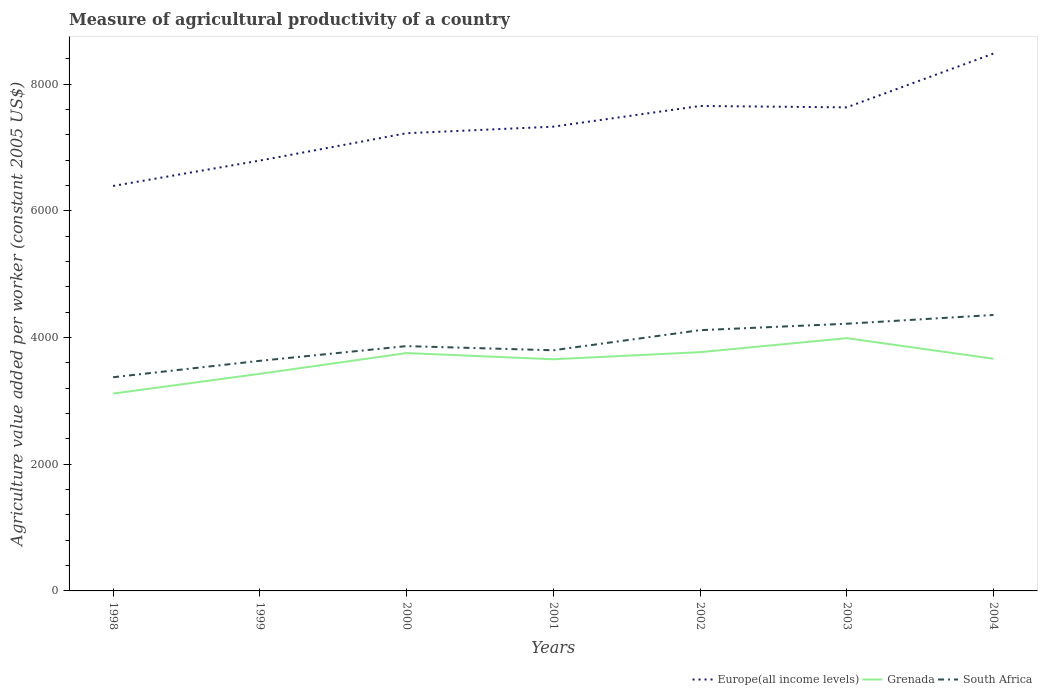How many different coloured lines are there?
Give a very brief answer. 3. Does the line corresponding to South Africa intersect with the line corresponding to Europe(all income levels)?
Your response must be concise. No. Across all years, what is the maximum measure of agricultural productivity in Grenada?
Offer a very short reply. 3116.04. In which year was the measure of agricultural productivity in South Africa maximum?
Your response must be concise. 1998. What is the total measure of agricultural productivity in South Africa in the graph?
Your answer should be very brief. -844.75. What is the difference between the highest and the second highest measure of agricultural productivity in Grenada?
Provide a succinct answer. 875.3. What is the difference between the highest and the lowest measure of agricultural productivity in Grenada?
Make the answer very short. 5. How many lines are there?
Your answer should be very brief. 3. Does the graph contain any zero values?
Ensure brevity in your answer.  No. How are the legend labels stacked?
Provide a succinct answer. Horizontal. What is the title of the graph?
Offer a terse response. Measure of agricultural productivity of a country. What is the label or title of the X-axis?
Ensure brevity in your answer.  Years. What is the label or title of the Y-axis?
Your answer should be compact. Agriculture value added per worker (constant 2005 US$). What is the Agriculture value added per worker (constant 2005 US$) in Europe(all income levels) in 1998?
Your answer should be very brief. 6394.67. What is the Agriculture value added per worker (constant 2005 US$) in Grenada in 1998?
Offer a terse response. 3116.04. What is the Agriculture value added per worker (constant 2005 US$) in South Africa in 1998?
Keep it short and to the point. 3374.27. What is the Agriculture value added per worker (constant 2005 US$) of Europe(all income levels) in 1999?
Your answer should be very brief. 6795.55. What is the Agriculture value added per worker (constant 2005 US$) of Grenada in 1999?
Provide a short and direct response. 3428.29. What is the Agriculture value added per worker (constant 2005 US$) of South Africa in 1999?
Provide a succinct answer. 3633.44. What is the Agriculture value added per worker (constant 2005 US$) of Europe(all income levels) in 2000?
Keep it short and to the point. 7227.25. What is the Agriculture value added per worker (constant 2005 US$) in Grenada in 2000?
Your answer should be very brief. 3755.84. What is the Agriculture value added per worker (constant 2005 US$) of South Africa in 2000?
Ensure brevity in your answer.  3865.82. What is the Agriculture value added per worker (constant 2005 US$) in Europe(all income levels) in 2001?
Provide a succinct answer. 7330.74. What is the Agriculture value added per worker (constant 2005 US$) in Grenada in 2001?
Make the answer very short. 3657.95. What is the Agriculture value added per worker (constant 2005 US$) in South Africa in 2001?
Ensure brevity in your answer.  3799.78. What is the Agriculture value added per worker (constant 2005 US$) in Europe(all income levels) in 2002?
Ensure brevity in your answer.  7657.57. What is the Agriculture value added per worker (constant 2005 US$) in Grenada in 2002?
Offer a very short reply. 3770.12. What is the Agriculture value added per worker (constant 2005 US$) of South Africa in 2002?
Ensure brevity in your answer.  4117.37. What is the Agriculture value added per worker (constant 2005 US$) in Europe(all income levels) in 2003?
Keep it short and to the point. 7635.81. What is the Agriculture value added per worker (constant 2005 US$) of Grenada in 2003?
Your response must be concise. 3991.34. What is the Agriculture value added per worker (constant 2005 US$) in South Africa in 2003?
Provide a short and direct response. 4219.01. What is the Agriculture value added per worker (constant 2005 US$) of Europe(all income levels) in 2004?
Your response must be concise. 8484.98. What is the Agriculture value added per worker (constant 2005 US$) of Grenada in 2004?
Your answer should be compact. 3666.22. What is the Agriculture value added per worker (constant 2005 US$) of South Africa in 2004?
Make the answer very short. 4357.4. Across all years, what is the maximum Agriculture value added per worker (constant 2005 US$) in Europe(all income levels)?
Make the answer very short. 8484.98. Across all years, what is the maximum Agriculture value added per worker (constant 2005 US$) of Grenada?
Make the answer very short. 3991.34. Across all years, what is the maximum Agriculture value added per worker (constant 2005 US$) of South Africa?
Your answer should be very brief. 4357.4. Across all years, what is the minimum Agriculture value added per worker (constant 2005 US$) in Europe(all income levels)?
Make the answer very short. 6394.67. Across all years, what is the minimum Agriculture value added per worker (constant 2005 US$) in Grenada?
Your answer should be very brief. 3116.04. Across all years, what is the minimum Agriculture value added per worker (constant 2005 US$) of South Africa?
Offer a very short reply. 3374.27. What is the total Agriculture value added per worker (constant 2005 US$) of Europe(all income levels) in the graph?
Your answer should be compact. 5.15e+04. What is the total Agriculture value added per worker (constant 2005 US$) in Grenada in the graph?
Your answer should be compact. 2.54e+04. What is the total Agriculture value added per worker (constant 2005 US$) in South Africa in the graph?
Offer a very short reply. 2.74e+04. What is the difference between the Agriculture value added per worker (constant 2005 US$) of Europe(all income levels) in 1998 and that in 1999?
Make the answer very short. -400.88. What is the difference between the Agriculture value added per worker (constant 2005 US$) of Grenada in 1998 and that in 1999?
Make the answer very short. -312.25. What is the difference between the Agriculture value added per worker (constant 2005 US$) in South Africa in 1998 and that in 1999?
Make the answer very short. -259.17. What is the difference between the Agriculture value added per worker (constant 2005 US$) of Europe(all income levels) in 1998 and that in 2000?
Give a very brief answer. -832.58. What is the difference between the Agriculture value added per worker (constant 2005 US$) of Grenada in 1998 and that in 2000?
Keep it short and to the point. -639.8. What is the difference between the Agriculture value added per worker (constant 2005 US$) of South Africa in 1998 and that in 2000?
Offer a very short reply. -491.55. What is the difference between the Agriculture value added per worker (constant 2005 US$) of Europe(all income levels) in 1998 and that in 2001?
Provide a short and direct response. -936.06. What is the difference between the Agriculture value added per worker (constant 2005 US$) of Grenada in 1998 and that in 2001?
Offer a terse response. -541.91. What is the difference between the Agriculture value added per worker (constant 2005 US$) in South Africa in 1998 and that in 2001?
Provide a succinct answer. -425.51. What is the difference between the Agriculture value added per worker (constant 2005 US$) in Europe(all income levels) in 1998 and that in 2002?
Make the answer very short. -1262.9. What is the difference between the Agriculture value added per worker (constant 2005 US$) of Grenada in 1998 and that in 2002?
Provide a succinct answer. -654.08. What is the difference between the Agriculture value added per worker (constant 2005 US$) of South Africa in 1998 and that in 2002?
Offer a terse response. -743.1. What is the difference between the Agriculture value added per worker (constant 2005 US$) of Europe(all income levels) in 1998 and that in 2003?
Give a very brief answer. -1241.14. What is the difference between the Agriculture value added per worker (constant 2005 US$) in Grenada in 1998 and that in 2003?
Keep it short and to the point. -875.3. What is the difference between the Agriculture value added per worker (constant 2005 US$) of South Africa in 1998 and that in 2003?
Offer a very short reply. -844.75. What is the difference between the Agriculture value added per worker (constant 2005 US$) of Europe(all income levels) in 1998 and that in 2004?
Ensure brevity in your answer.  -2090.31. What is the difference between the Agriculture value added per worker (constant 2005 US$) of Grenada in 1998 and that in 2004?
Offer a very short reply. -550.18. What is the difference between the Agriculture value added per worker (constant 2005 US$) in South Africa in 1998 and that in 2004?
Provide a short and direct response. -983.13. What is the difference between the Agriculture value added per worker (constant 2005 US$) in Europe(all income levels) in 1999 and that in 2000?
Your answer should be compact. -431.7. What is the difference between the Agriculture value added per worker (constant 2005 US$) in Grenada in 1999 and that in 2000?
Your answer should be compact. -327.55. What is the difference between the Agriculture value added per worker (constant 2005 US$) of South Africa in 1999 and that in 2000?
Ensure brevity in your answer.  -232.38. What is the difference between the Agriculture value added per worker (constant 2005 US$) in Europe(all income levels) in 1999 and that in 2001?
Offer a very short reply. -535.18. What is the difference between the Agriculture value added per worker (constant 2005 US$) of Grenada in 1999 and that in 2001?
Provide a short and direct response. -229.66. What is the difference between the Agriculture value added per worker (constant 2005 US$) in South Africa in 1999 and that in 2001?
Offer a terse response. -166.34. What is the difference between the Agriculture value added per worker (constant 2005 US$) in Europe(all income levels) in 1999 and that in 2002?
Provide a succinct answer. -862.02. What is the difference between the Agriculture value added per worker (constant 2005 US$) in Grenada in 1999 and that in 2002?
Offer a terse response. -341.83. What is the difference between the Agriculture value added per worker (constant 2005 US$) of South Africa in 1999 and that in 2002?
Your answer should be very brief. -483.93. What is the difference between the Agriculture value added per worker (constant 2005 US$) of Europe(all income levels) in 1999 and that in 2003?
Give a very brief answer. -840.26. What is the difference between the Agriculture value added per worker (constant 2005 US$) of Grenada in 1999 and that in 2003?
Keep it short and to the point. -563.05. What is the difference between the Agriculture value added per worker (constant 2005 US$) of South Africa in 1999 and that in 2003?
Make the answer very short. -585.57. What is the difference between the Agriculture value added per worker (constant 2005 US$) in Europe(all income levels) in 1999 and that in 2004?
Make the answer very short. -1689.43. What is the difference between the Agriculture value added per worker (constant 2005 US$) in Grenada in 1999 and that in 2004?
Offer a terse response. -237.93. What is the difference between the Agriculture value added per worker (constant 2005 US$) of South Africa in 1999 and that in 2004?
Your answer should be very brief. -723.96. What is the difference between the Agriculture value added per worker (constant 2005 US$) in Europe(all income levels) in 2000 and that in 2001?
Provide a short and direct response. -103.48. What is the difference between the Agriculture value added per worker (constant 2005 US$) in Grenada in 2000 and that in 2001?
Give a very brief answer. 97.89. What is the difference between the Agriculture value added per worker (constant 2005 US$) of South Africa in 2000 and that in 2001?
Your response must be concise. 66.04. What is the difference between the Agriculture value added per worker (constant 2005 US$) in Europe(all income levels) in 2000 and that in 2002?
Your answer should be compact. -430.32. What is the difference between the Agriculture value added per worker (constant 2005 US$) of Grenada in 2000 and that in 2002?
Offer a very short reply. -14.28. What is the difference between the Agriculture value added per worker (constant 2005 US$) in South Africa in 2000 and that in 2002?
Offer a very short reply. -251.55. What is the difference between the Agriculture value added per worker (constant 2005 US$) of Europe(all income levels) in 2000 and that in 2003?
Offer a terse response. -408.56. What is the difference between the Agriculture value added per worker (constant 2005 US$) of Grenada in 2000 and that in 2003?
Offer a very short reply. -235.5. What is the difference between the Agriculture value added per worker (constant 2005 US$) of South Africa in 2000 and that in 2003?
Provide a short and direct response. -353.19. What is the difference between the Agriculture value added per worker (constant 2005 US$) of Europe(all income levels) in 2000 and that in 2004?
Provide a succinct answer. -1257.73. What is the difference between the Agriculture value added per worker (constant 2005 US$) of Grenada in 2000 and that in 2004?
Make the answer very short. 89.62. What is the difference between the Agriculture value added per worker (constant 2005 US$) in South Africa in 2000 and that in 2004?
Your response must be concise. -491.58. What is the difference between the Agriculture value added per worker (constant 2005 US$) of Europe(all income levels) in 2001 and that in 2002?
Your answer should be very brief. -326.84. What is the difference between the Agriculture value added per worker (constant 2005 US$) of Grenada in 2001 and that in 2002?
Offer a very short reply. -112.17. What is the difference between the Agriculture value added per worker (constant 2005 US$) of South Africa in 2001 and that in 2002?
Keep it short and to the point. -317.59. What is the difference between the Agriculture value added per worker (constant 2005 US$) in Europe(all income levels) in 2001 and that in 2003?
Offer a very short reply. -305.08. What is the difference between the Agriculture value added per worker (constant 2005 US$) in Grenada in 2001 and that in 2003?
Offer a very short reply. -333.39. What is the difference between the Agriculture value added per worker (constant 2005 US$) in South Africa in 2001 and that in 2003?
Provide a succinct answer. -419.23. What is the difference between the Agriculture value added per worker (constant 2005 US$) in Europe(all income levels) in 2001 and that in 2004?
Give a very brief answer. -1154.24. What is the difference between the Agriculture value added per worker (constant 2005 US$) of Grenada in 2001 and that in 2004?
Your answer should be very brief. -8.27. What is the difference between the Agriculture value added per worker (constant 2005 US$) in South Africa in 2001 and that in 2004?
Provide a short and direct response. -557.62. What is the difference between the Agriculture value added per worker (constant 2005 US$) in Europe(all income levels) in 2002 and that in 2003?
Your response must be concise. 21.76. What is the difference between the Agriculture value added per worker (constant 2005 US$) of Grenada in 2002 and that in 2003?
Keep it short and to the point. -221.22. What is the difference between the Agriculture value added per worker (constant 2005 US$) in South Africa in 2002 and that in 2003?
Ensure brevity in your answer.  -101.65. What is the difference between the Agriculture value added per worker (constant 2005 US$) in Europe(all income levels) in 2002 and that in 2004?
Your response must be concise. -827.41. What is the difference between the Agriculture value added per worker (constant 2005 US$) in Grenada in 2002 and that in 2004?
Provide a succinct answer. 103.9. What is the difference between the Agriculture value added per worker (constant 2005 US$) in South Africa in 2002 and that in 2004?
Ensure brevity in your answer.  -240.03. What is the difference between the Agriculture value added per worker (constant 2005 US$) in Europe(all income levels) in 2003 and that in 2004?
Provide a succinct answer. -849.17. What is the difference between the Agriculture value added per worker (constant 2005 US$) of Grenada in 2003 and that in 2004?
Provide a succinct answer. 325.12. What is the difference between the Agriculture value added per worker (constant 2005 US$) in South Africa in 2003 and that in 2004?
Offer a very short reply. -138.39. What is the difference between the Agriculture value added per worker (constant 2005 US$) of Europe(all income levels) in 1998 and the Agriculture value added per worker (constant 2005 US$) of Grenada in 1999?
Your response must be concise. 2966.38. What is the difference between the Agriculture value added per worker (constant 2005 US$) in Europe(all income levels) in 1998 and the Agriculture value added per worker (constant 2005 US$) in South Africa in 1999?
Provide a succinct answer. 2761.24. What is the difference between the Agriculture value added per worker (constant 2005 US$) of Grenada in 1998 and the Agriculture value added per worker (constant 2005 US$) of South Africa in 1999?
Offer a very short reply. -517.4. What is the difference between the Agriculture value added per worker (constant 2005 US$) of Europe(all income levels) in 1998 and the Agriculture value added per worker (constant 2005 US$) of Grenada in 2000?
Offer a very short reply. 2638.83. What is the difference between the Agriculture value added per worker (constant 2005 US$) of Europe(all income levels) in 1998 and the Agriculture value added per worker (constant 2005 US$) of South Africa in 2000?
Offer a very short reply. 2528.86. What is the difference between the Agriculture value added per worker (constant 2005 US$) in Grenada in 1998 and the Agriculture value added per worker (constant 2005 US$) in South Africa in 2000?
Ensure brevity in your answer.  -749.78. What is the difference between the Agriculture value added per worker (constant 2005 US$) in Europe(all income levels) in 1998 and the Agriculture value added per worker (constant 2005 US$) in Grenada in 2001?
Give a very brief answer. 2736.72. What is the difference between the Agriculture value added per worker (constant 2005 US$) of Europe(all income levels) in 1998 and the Agriculture value added per worker (constant 2005 US$) of South Africa in 2001?
Your answer should be compact. 2594.89. What is the difference between the Agriculture value added per worker (constant 2005 US$) in Grenada in 1998 and the Agriculture value added per worker (constant 2005 US$) in South Africa in 2001?
Your answer should be very brief. -683.74. What is the difference between the Agriculture value added per worker (constant 2005 US$) in Europe(all income levels) in 1998 and the Agriculture value added per worker (constant 2005 US$) in Grenada in 2002?
Offer a terse response. 2624.55. What is the difference between the Agriculture value added per worker (constant 2005 US$) in Europe(all income levels) in 1998 and the Agriculture value added per worker (constant 2005 US$) in South Africa in 2002?
Offer a terse response. 2277.31. What is the difference between the Agriculture value added per worker (constant 2005 US$) of Grenada in 1998 and the Agriculture value added per worker (constant 2005 US$) of South Africa in 2002?
Your answer should be compact. -1001.32. What is the difference between the Agriculture value added per worker (constant 2005 US$) in Europe(all income levels) in 1998 and the Agriculture value added per worker (constant 2005 US$) in Grenada in 2003?
Offer a very short reply. 2403.33. What is the difference between the Agriculture value added per worker (constant 2005 US$) in Europe(all income levels) in 1998 and the Agriculture value added per worker (constant 2005 US$) in South Africa in 2003?
Provide a succinct answer. 2175.66. What is the difference between the Agriculture value added per worker (constant 2005 US$) of Grenada in 1998 and the Agriculture value added per worker (constant 2005 US$) of South Africa in 2003?
Provide a succinct answer. -1102.97. What is the difference between the Agriculture value added per worker (constant 2005 US$) in Europe(all income levels) in 1998 and the Agriculture value added per worker (constant 2005 US$) in Grenada in 2004?
Your answer should be compact. 2728.45. What is the difference between the Agriculture value added per worker (constant 2005 US$) of Europe(all income levels) in 1998 and the Agriculture value added per worker (constant 2005 US$) of South Africa in 2004?
Make the answer very short. 2037.28. What is the difference between the Agriculture value added per worker (constant 2005 US$) of Grenada in 1998 and the Agriculture value added per worker (constant 2005 US$) of South Africa in 2004?
Your answer should be very brief. -1241.36. What is the difference between the Agriculture value added per worker (constant 2005 US$) of Europe(all income levels) in 1999 and the Agriculture value added per worker (constant 2005 US$) of Grenada in 2000?
Offer a very short reply. 3039.71. What is the difference between the Agriculture value added per worker (constant 2005 US$) of Europe(all income levels) in 1999 and the Agriculture value added per worker (constant 2005 US$) of South Africa in 2000?
Provide a succinct answer. 2929.74. What is the difference between the Agriculture value added per worker (constant 2005 US$) in Grenada in 1999 and the Agriculture value added per worker (constant 2005 US$) in South Africa in 2000?
Make the answer very short. -437.52. What is the difference between the Agriculture value added per worker (constant 2005 US$) in Europe(all income levels) in 1999 and the Agriculture value added per worker (constant 2005 US$) in Grenada in 2001?
Your response must be concise. 3137.6. What is the difference between the Agriculture value added per worker (constant 2005 US$) in Europe(all income levels) in 1999 and the Agriculture value added per worker (constant 2005 US$) in South Africa in 2001?
Make the answer very short. 2995.77. What is the difference between the Agriculture value added per worker (constant 2005 US$) of Grenada in 1999 and the Agriculture value added per worker (constant 2005 US$) of South Africa in 2001?
Ensure brevity in your answer.  -371.49. What is the difference between the Agriculture value added per worker (constant 2005 US$) of Europe(all income levels) in 1999 and the Agriculture value added per worker (constant 2005 US$) of Grenada in 2002?
Your response must be concise. 3025.43. What is the difference between the Agriculture value added per worker (constant 2005 US$) in Europe(all income levels) in 1999 and the Agriculture value added per worker (constant 2005 US$) in South Africa in 2002?
Your answer should be very brief. 2678.19. What is the difference between the Agriculture value added per worker (constant 2005 US$) of Grenada in 1999 and the Agriculture value added per worker (constant 2005 US$) of South Africa in 2002?
Provide a short and direct response. -689.07. What is the difference between the Agriculture value added per worker (constant 2005 US$) in Europe(all income levels) in 1999 and the Agriculture value added per worker (constant 2005 US$) in Grenada in 2003?
Your answer should be very brief. 2804.21. What is the difference between the Agriculture value added per worker (constant 2005 US$) in Europe(all income levels) in 1999 and the Agriculture value added per worker (constant 2005 US$) in South Africa in 2003?
Your answer should be compact. 2576.54. What is the difference between the Agriculture value added per worker (constant 2005 US$) of Grenada in 1999 and the Agriculture value added per worker (constant 2005 US$) of South Africa in 2003?
Make the answer very short. -790.72. What is the difference between the Agriculture value added per worker (constant 2005 US$) of Europe(all income levels) in 1999 and the Agriculture value added per worker (constant 2005 US$) of Grenada in 2004?
Give a very brief answer. 3129.33. What is the difference between the Agriculture value added per worker (constant 2005 US$) in Europe(all income levels) in 1999 and the Agriculture value added per worker (constant 2005 US$) in South Africa in 2004?
Offer a very short reply. 2438.15. What is the difference between the Agriculture value added per worker (constant 2005 US$) of Grenada in 1999 and the Agriculture value added per worker (constant 2005 US$) of South Africa in 2004?
Provide a short and direct response. -929.11. What is the difference between the Agriculture value added per worker (constant 2005 US$) in Europe(all income levels) in 2000 and the Agriculture value added per worker (constant 2005 US$) in Grenada in 2001?
Provide a short and direct response. 3569.3. What is the difference between the Agriculture value added per worker (constant 2005 US$) of Europe(all income levels) in 2000 and the Agriculture value added per worker (constant 2005 US$) of South Africa in 2001?
Ensure brevity in your answer.  3427.47. What is the difference between the Agriculture value added per worker (constant 2005 US$) in Grenada in 2000 and the Agriculture value added per worker (constant 2005 US$) in South Africa in 2001?
Ensure brevity in your answer.  -43.94. What is the difference between the Agriculture value added per worker (constant 2005 US$) in Europe(all income levels) in 2000 and the Agriculture value added per worker (constant 2005 US$) in Grenada in 2002?
Make the answer very short. 3457.13. What is the difference between the Agriculture value added per worker (constant 2005 US$) of Europe(all income levels) in 2000 and the Agriculture value added per worker (constant 2005 US$) of South Africa in 2002?
Your answer should be compact. 3109.89. What is the difference between the Agriculture value added per worker (constant 2005 US$) of Grenada in 2000 and the Agriculture value added per worker (constant 2005 US$) of South Africa in 2002?
Give a very brief answer. -361.52. What is the difference between the Agriculture value added per worker (constant 2005 US$) in Europe(all income levels) in 2000 and the Agriculture value added per worker (constant 2005 US$) in Grenada in 2003?
Your answer should be very brief. 3235.91. What is the difference between the Agriculture value added per worker (constant 2005 US$) in Europe(all income levels) in 2000 and the Agriculture value added per worker (constant 2005 US$) in South Africa in 2003?
Keep it short and to the point. 3008.24. What is the difference between the Agriculture value added per worker (constant 2005 US$) of Grenada in 2000 and the Agriculture value added per worker (constant 2005 US$) of South Africa in 2003?
Offer a terse response. -463.17. What is the difference between the Agriculture value added per worker (constant 2005 US$) of Europe(all income levels) in 2000 and the Agriculture value added per worker (constant 2005 US$) of Grenada in 2004?
Your answer should be very brief. 3561.03. What is the difference between the Agriculture value added per worker (constant 2005 US$) of Europe(all income levels) in 2000 and the Agriculture value added per worker (constant 2005 US$) of South Africa in 2004?
Provide a short and direct response. 2869.85. What is the difference between the Agriculture value added per worker (constant 2005 US$) in Grenada in 2000 and the Agriculture value added per worker (constant 2005 US$) in South Africa in 2004?
Your response must be concise. -601.55. What is the difference between the Agriculture value added per worker (constant 2005 US$) in Europe(all income levels) in 2001 and the Agriculture value added per worker (constant 2005 US$) in Grenada in 2002?
Offer a terse response. 3560.61. What is the difference between the Agriculture value added per worker (constant 2005 US$) in Europe(all income levels) in 2001 and the Agriculture value added per worker (constant 2005 US$) in South Africa in 2002?
Your answer should be compact. 3213.37. What is the difference between the Agriculture value added per worker (constant 2005 US$) of Grenada in 2001 and the Agriculture value added per worker (constant 2005 US$) of South Africa in 2002?
Ensure brevity in your answer.  -459.41. What is the difference between the Agriculture value added per worker (constant 2005 US$) in Europe(all income levels) in 2001 and the Agriculture value added per worker (constant 2005 US$) in Grenada in 2003?
Offer a very short reply. 3339.39. What is the difference between the Agriculture value added per worker (constant 2005 US$) of Europe(all income levels) in 2001 and the Agriculture value added per worker (constant 2005 US$) of South Africa in 2003?
Keep it short and to the point. 3111.72. What is the difference between the Agriculture value added per worker (constant 2005 US$) in Grenada in 2001 and the Agriculture value added per worker (constant 2005 US$) in South Africa in 2003?
Offer a terse response. -561.06. What is the difference between the Agriculture value added per worker (constant 2005 US$) in Europe(all income levels) in 2001 and the Agriculture value added per worker (constant 2005 US$) in Grenada in 2004?
Offer a very short reply. 3664.52. What is the difference between the Agriculture value added per worker (constant 2005 US$) of Europe(all income levels) in 2001 and the Agriculture value added per worker (constant 2005 US$) of South Africa in 2004?
Give a very brief answer. 2973.34. What is the difference between the Agriculture value added per worker (constant 2005 US$) in Grenada in 2001 and the Agriculture value added per worker (constant 2005 US$) in South Africa in 2004?
Offer a very short reply. -699.45. What is the difference between the Agriculture value added per worker (constant 2005 US$) in Europe(all income levels) in 2002 and the Agriculture value added per worker (constant 2005 US$) in Grenada in 2003?
Offer a very short reply. 3666.23. What is the difference between the Agriculture value added per worker (constant 2005 US$) of Europe(all income levels) in 2002 and the Agriculture value added per worker (constant 2005 US$) of South Africa in 2003?
Your answer should be compact. 3438.56. What is the difference between the Agriculture value added per worker (constant 2005 US$) in Grenada in 2002 and the Agriculture value added per worker (constant 2005 US$) in South Africa in 2003?
Give a very brief answer. -448.89. What is the difference between the Agriculture value added per worker (constant 2005 US$) in Europe(all income levels) in 2002 and the Agriculture value added per worker (constant 2005 US$) in Grenada in 2004?
Provide a short and direct response. 3991.35. What is the difference between the Agriculture value added per worker (constant 2005 US$) of Europe(all income levels) in 2002 and the Agriculture value added per worker (constant 2005 US$) of South Africa in 2004?
Your answer should be very brief. 3300.17. What is the difference between the Agriculture value added per worker (constant 2005 US$) of Grenada in 2002 and the Agriculture value added per worker (constant 2005 US$) of South Africa in 2004?
Your answer should be compact. -587.28. What is the difference between the Agriculture value added per worker (constant 2005 US$) in Europe(all income levels) in 2003 and the Agriculture value added per worker (constant 2005 US$) in Grenada in 2004?
Provide a succinct answer. 3969.59. What is the difference between the Agriculture value added per worker (constant 2005 US$) of Europe(all income levels) in 2003 and the Agriculture value added per worker (constant 2005 US$) of South Africa in 2004?
Provide a succinct answer. 3278.41. What is the difference between the Agriculture value added per worker (constant 2005 US$) in Grenada in 2003 and the Agriculture value added per worker (constant 2005 US$) in South Africa in 2004?
Offer a very short reply. -366.06. What is the average Agriculture value added per worker (constant 2005 US$) in Europe(all income levels) per year?
Your answer should be compact. 7360.94. What is the average Agriculture value added per worker (constant 2005 US$) of Grenada per year?
Provide a succinct answer. 3626.55. What is the average Agriculture value added per worker (constant 2005 US$) of South Africa per year?
Your response must be concise. 3909.58. In the year 1998, what is the difference between the Agriculture value added per worker (constant 2005 US$) of Europe(all income levels) and Agriculture value added per worker (constant 2005 US$) of Grenada?
Your answer should be compact. 3278.63. In the year 1998, what is the difference between the Agriculture value added per worker (constant 2005 US$) of Europe(all income levels) and Agriculture value added per worker (constant 2005 US$) of South Africa?
Offer a terse response. 3020.41. In the year 1998, what is the difference between the Agriculture value added per worker (constant 2005 US$) of Grenada and Agriculture value added per worker (constant 2005 US$) of South Africa?
Your response must be concise. -258.22. In the year 1999, what is the difference between the Agriculture value added per worker (constant 2005 US$) of Europe(all income levels) and Agriculture value added per worker (constant 2005 US$) of Grenada?
Offer a very short reply. 3367.26. In the year 1999, what is the difference between the Agriculture value added per worker (constant 2005 US$) of Europe(all income levels) and Agriculture value added per worker (constant 2005 US$) of South Africa?
Make the answer very short. 3162.11. In the year 1999, what is the difference between the Agriculture value added per worker (constant 2005 US$) of Grenada and Agriculture value added per worker (constant 2005 US$) of South Africa?
Ensure brevity in your answer.  -205.15. In the year 2000, what is the difference between the Agriculture value added per worker (constant 2005 US$) of Europe(all income levels) and Agriculture value added per worker (constant 2005 US$) of Grenada?
Provide a succinct answer. 3471.41. In the year 2000, what is the difference between the Agriculture value added per worker (constant 2005 US$) of Europe(all income levels) and Agriculture value added per worker (constant 2005 US$) of South Africa?
Offer a very short reply. 3361.44. In the year 2000, what is the difference between the Agriculture value added per worker (constant 2005 US$) of Grenada and Agriculture value added per worker (constant 2005 US$) of South Africa?
Provide a short and direct response. -109.97. In the year 2001, what is the difference between the Agriculture value added per worker (constant 2005 US$) in Europe(all income levels) and Agriculture value added per worker (constant 2005 US$) in Grenada?
Offer a terse response. 3672.78. In the year 2001, what is the difference between the Agriculture value added per worker (constant 2005 US$) in Europe(all income levels) and Agriculture value added per worker (constant 2005 US$) in South Africa?
Your answer should be very brief. 3530.96. In the year 2001, what is the difference between the Agriculture value added per worker (constant 2005 US$) of Grenada and Agriculture value added per worker (constant 2005 US$) of South Africa?
Your answer should be compact. -141.83. In the year 2002, what is the difference between the Agriculture value added per worker (constant 2005 US$) in Europe(all income levels) and Agriculture value added per worker (constant 2005 US$) in Grenada?
Ensure brevity in your answer.  3887.45. In the year 2002, what is the difference between the Agriculture value added per worker (constant 2005 US$) of Europe(all income levels) and Agriculture value added per worker (constant 2005 US$) of South Africa?
Your answer should be very brief. 3540.21. In the year 2002, what is the difference between the Agriculture value added per worker (constant 2005 US$) of Grenada and Agriculture value added per worker (constant 2005 US$) of South Africa?
Ensure brevity in your answer.  -347.24. In the year 2003, what is the difference between the Agriculture value added per worker (constant 2005 US$) in Europe(all income levels) and Agriculture value added per worker (constant 2005 US$) in Grenada?
Keep it short and to the point. 3644.47. In the year 2003, what is the difference between the Agriculture value added per worker (constant 2005 US$) in Europe(all income levels) and Agriculture value added per worker (constant 2005 US$) in South Africa?
Make the answer very short. 3416.8. In the year 2003, what is the difference between the Agriculture value added per worker (constant 2005 US$) of Grenada and Agriculture value added per worker (constant 2005 US$) of South Africa?
Keep it short and to the point. -227.67. In the year 2004, what is the difference between the Agriculture value added per worker (constant 2005 US$) in Europe(all income levels) and Agriculture value added per worker (constant 2005 US$) in Grenada?
Give a very brief answer. 4818.76. In the year 2004, what is the difference between the Agriculture value added per worker (constant 2005 US$) in Europe(all income levels) and Agriculture value added per worker (constant 2005 US$) in South Africa?
Offer a very short reply. 4127.58. In the year 2004, what is the difference between the Agriculture value added per worker (constant 2005 US$) in Grenada and Agriculture value added per worker (constant 2005 US$) in South Africa?
Keep it short and to the point. -691.18. What is the ratio of the Agriculture value added per worker (constant 2005 US$) of Europe(all income levels) in 1998 to that in 1999?
Provide a short and direct response. 0.94. What is the ratio of the Agriculture value added per worker (constant 2005 US$) of Grenada in 1998 to that in 1999?
Your response must be concise. 0.91. What is the ratio of the Agriculture value added per worker (constant 2005 US$) of South Africa in 1998 to that in 1999?
Your response must be concise. 0.93. What is the ratio of the Agriculture value added per worker (constant 2005 US$) of Europe(all income levels) in 1998 to that in 2000?
Make the answer very short. 0.88. What is the ratio of the Agriculture value added per worker (constant 2005 US$) of Grenada in 1998 to that in 2000?
Your answer should be compact. 0.83. What is the ratio of the Agriculture value added per worker (constant 2005 US$) in South Africa in 1998 to that in 2000?
Provide a succinct answer. 0.87. What is the ratio of the Agriculture value added per worker (constant 2005 US$) of Europe(all income levels) in 1998 to that in 2001?
Offer a very short reply. 0.87. What is the ratio of the Agriculture value added per worker (constant 2005 US$) of Grenada in 1998 to that in 2001?
Provide a succinct answer. 0.85. What is the ratio of the Agriculture value added per worker (constant 2005 US$) of South Africa in 1998 to that in 2001?
Provide a short and direct response. 0.89. What is the ratio of the Agriculture value added per worker (constant 2005 US$) of Europe(all income levels) in 1998 to that in 2002?
Offer a very short reply. 0.84. What is the ratio of the Agriculture value added per worker (constant 2005 US$) in Grenada in 1998 to that in 2002?
Your answer should be compact. 0.83. What is the ratio of the Agriculture value added per worker (constant 2005 US$) of South Africa in 1998 to that in 2002?
Your answer should be very brief. 0.82. What is the ratio of the Agriculture value added per worker (constant 2005 US$) in Europe(all income levels) in 1998 to that in 2003?
Your response must be concise. 0.84. What is the ratio of the Agriculture value added per worker (constant 2005 US$) in Grenada in 1998 to that in 2003?
Your answer should be very brief. 0.78. What is the ratio of the Agriculture value added per worker (constant 2005 US$) in South Africa in 1998 to that in 2003?
Provide a succinct answer. 0.8. What is the ratio of the Agriculture value added per worker (constant 2005 US$) of Europe(all income levels) in 1998 to that in 2004?
Keep it short and to the point. 0.75. What is the ratio of the Agriculture value added per worker (constant 2005 US$) of Grenada in 1998 to that in 2004?
Ensure brevity in your answer.  0.85. What is the ratio of the Agriculture value added per worker (constant 2005 US$) of South Africa in 1998 to that in 2004?
Offer a very short reply. 0.77. What is the ratio of the Agriculture value added per worker (constant 2005 US$) of Europe(all income levels) in 1999 to that in 2000?
Your answer should be compact. 0.94. What is the ratio of the Agriculture value added per worker (constant 2005 US$) in Grenada in 1999 to that in 2000?
Your response must be concise. 0.91. What is the ratio of the Agriculture value added per worker (constant 2005 US$) of South Africa in 1999 to that in 2000?
Provide a succinct answer. 0.94. What is the ratio of the Agriculture value added per worker (constant 2005 US$) of Europe(all income levels) in 1999 to that in 2001?
Your response must be concise. 0.93. What is the ratio of the Agriculture value added per worker (constant 2005 US$) in Grenada in 1999 to that in 2001?
Offer a very short reply. 0.94. What is the ratio of the Agriculture value added per worker (constant 2005 US$) of South Africa in 1999 to that in 2001?
Your answer should be compact. 0.96. What is the ratio of the Agriculture value added per worker (constant 2005 US$) of Europe(all income levels) in 1999 to that in 2002?
Your response must be concise. 0.89. What is the ratio of the Agriculture value added per worker (constant 2005 US$) in Grenada in 1999 to that in 2002?
Your answer should be very brief. 0.91. What is the ratio of the Agriculture value added per worker (constant 2005 US$) of South Africa in 1999 to that in 2002?
Your response must be concise. 0.88. What is the ratio of the Agriculture value added per worker (constant 2005 US$) in Europe(all income levels) in 1999 to that in 2003?
Provide a succinct answer. 0.89. What is the ratio of the Agriculture value added per worker (constant 2005 US$) of Grenada in 1999 to that in 2003?
Your answer should be very brief. 0.86. What is the ratio of the Agriculture value added per worker (constant 2005 US$) in South Africa in 1999 to that in 2003?
Provide a succinct answer. 0.86. What is the ratio of the Agriculture value added per worker (constant 2005 US$) in Europe(all income levels) in 1999 to that in 2004?
Keep it short and to the point. 0.8. What is the ratio of the Agriculture value added per worker (constant 2005 US$) of Grenada in 1999 to that in 2004?
Keep it short and to the point. 0.94. What is the ratio of the Agriculture value added per worker (constant 2005 US$) of South Africa in 1999 to that in 2004?
Offer a terse response. 0.83. What is the ratio of the Agriculture value added per worker (constant 2005 US$) in Europe(all income levels) in 2000 to that in 2001?
Provide a succinct answer. 0.99. What is the ratio of the Agriculture value added per worker (constant 2005 US$) in Grenada in 2000 to that in 2001?
Provide a short and direct response. 1.03. What is the ratio of the Agriculture value added per worker (constant 2005 US$) of South Africa in 2000 to that in 2001?
Provide a succinct answer. 1.02. What is the ratio of the Agriculture value added per worker (constant 2005 US$) of Europe(all income levels) in 2000 to that in 2002?
Offer a terse response. 0.94. What is the ratio of the Agriculture value added per worker (constant 2005 US$) in Grenada in 2000 to that in 2002?
Provide a short and direct response. 1. What is the ratio of the Agriculture value added per worker (constant 2005 US$) of South Africa in 2000 to that in 2002?
Make the answer very short. 0.94. What is the ratio of the Agriculture value added per worker (constant 2005 US$) of Europe(all income levels) in 2000 to that in 2003?
Ensure brevity in your answer.  0.95. What is the ratio of the Agriculture value added per worker (constant 2005 US$) of Grenada in 2000 to that in 2003?
Your answer should be compact. 0.94. What is the ratio of the Agriculture value added per worker (constant 2005 US$) of South Africa in 2000 to that in 2003?
Your response must be concise. 0.92. What is the ratio of the Agriculture value added per worker (constant 2005 US$) of Europe(all income levels) in 2000 to that in 2004?
Provide a succinct answer. 0.85. What is the ratio of the Agriculture value added per worker (constant 2005 US$) of Grenada in 2000 to that in 2004?
Offer a very short reply. 1.02. What is the ratio of the Agriculture value added per worker (constant 2005 US$) of South Africa in 2000 to that in 2004?
Offer a terse response. 0.89. What is the ratio of the Agriculture value added per worker (constant 2005 US$) of Europe(all income levels) in 2001 to that in 2002?
Offer a terse response. 0.96. What is the ratio of the Agriculture value added per worker (constant 2005 US$) in Grenada in 2001 to that in 2002?
Offer a terse response. 0.97. What is the ratio of the Agriculture value added per worker (constant 2005 US$) of South Africa in 2001 to that in 2002?
Your response must be concise. 0.92. What is the ratio of the Agriculture value added per worker (constant 2005 US$) of Europe(all income levels) in 2001 to that in 2003?
Offer a terse response. 0.96. What is the ratio of the Agriculture value added per worker (constant 2005 US$) in Grenada in 2001 to that in 2003?
Ensure brevity in your answer.  0.92. What is the ratio of the Agriculture value added per worker (constant 2005 US$) in South Africa in 2001 to that in 2003?
Your answer should be compact. 0.9. What is the ratio of the Agriculture value added per worker (constant 2005 US$) in Europe(all income levels) in 2001 to that in 2004?
Offer a terse response. 0.86. What is the ratio of the Agriculture value added per worker (constant 2005 US$) of South Africa in 2001 to that in 2004?
Ensure brevity in your answer.  0.87. What is the ratio of the Agriculture value added per worker (constant 2005 US$) in Grenada in 2002 to that in 2003?
Give a very brief answer. 0.94. What is the ratio of the Agriculture value added per worker (constant 2005 US$) in South Africa in 2002 to that in 2003?
Provide a short and direct response. 0.98. What is the ratio of the Agriculture value added per worker (constant 2005 US$) of Europe(all income levels) in 2002 to that in 2004?
Your answer should be compact. 0.9. What is the ratio of the Agriculture value added per worker (constant 2005 US$) in Grenada in 2002 to that in 2004?
Make the answer very short. 1.03. What is the ratio of the Agriculture value added per worker (constant 2005 US$) of South Africa in 2002 to that in 2004?
Give a very brief answer. 0.94. What is the ratio of the Agriculture value added per worker (constant 2005 US$) of Europe(all income levels) in 2003 to that in 2004?
Offer a terse response. 0.9. What is the ratio of the Agriculture value added per worker (constant 2005 US$) of Grenada in 2003 to that in 2004?
Provide a succinct answer. 1.09. What is the ratio of the Agriculture value added per worker (constant 2005 US$) of South Africa in 2003 to that in 2004?
Your answer should be compact. 0.97. What is the difference between the highest and the second highest Agriculture value added per worker (constant 2005 US$) in Europe(all income levels)?
Provide a short and direct response. 827.41. What is the difference between the highest and the second highest Agriculture value added per worker (constant 2005 US$) in Grenada?
Your answer should be very brief. 221.22. What is the difference between the highest and the second highest Agriculture value added per worker (constant 2005 US$) in South Africa?
Your answer should be compact. 138.39. What is the difference between the highest and the lowest Agriculture value added per worker (constant 2005 US$) of Europe(all income levels)?
Ensure brevity in your answer.  2090.31. What is the difference between the highest and the lowest Agriculture value added per worker (constant 2005 US$) of Grenada?
Offer a very short reply. 875.3. What is the difference between the highest and the lowest Agriculture value added per worker (constant 2005 US$) in South Africa?
Ensure brevity in your answer.  983.13. 